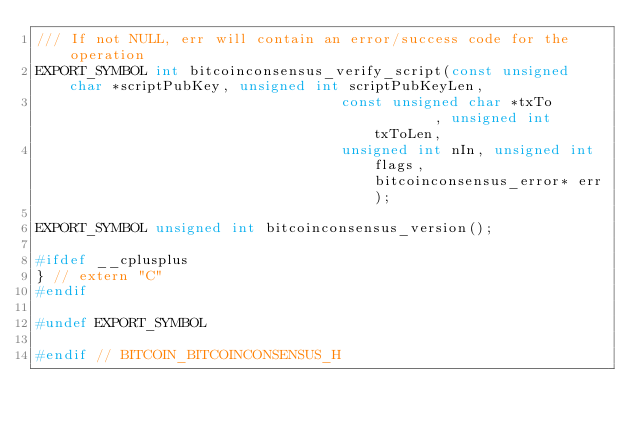<code> <loc_0><loc_0><loc_500><loc_500><_C_>/// If not NULL, err will contain an error/success code for the operation
EXPORT_SYMBOL int bitcoinconsensus_verify_script(const unsigned char *scriptPubKey, unsigned int scriptPubKeyLen,
                                    const unsigned char *txTo        , unsigned int txToLen,
                                    unsigned int nIn, unsigned int flags, bitcoinconsensus_error* err);

EXPORT_SYMBOL unsigned int bitcoinconsensus_version();

#ifdef __cplusplus
} // extern "C"
#endif

#undef EXPORT_SYMBOL

#endif // BITCOIN_BITCOINCONSENSUS_H
</code> 